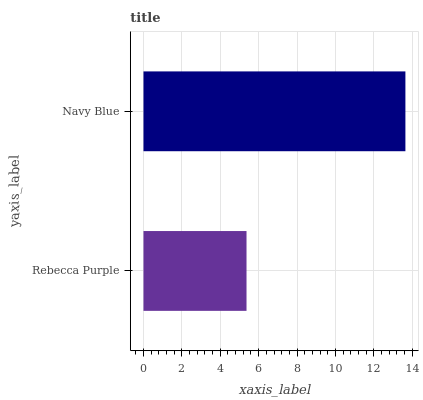Is Rebecca Purple the minimum?
Answer yes or no. Yes. Is Navy Blue the maximum?
Answer yes or no. Yes. Is Navy Blue the minimum?
Answer yes or no. No. Is Navy Blue greater than Rebecca Purple?
Answer yes or no. Yes. Is Rebecca Purple less than Navy Blue?
Answer yes or no. Yes. Is Rebecca Purple greater than Navy Blue?
Answer yes or no. No. Is Navy Blue less than Rebecca Purple?
Answer yes or no. No. Is Navy Blue the high median?
Answer yes or no. Yes. Is Rebecca Purple the low median?
Answer yes or no. Yes. Is Rebecca Purple the high median?
Answer yes or no. No. Is Navy Blue the low median?
Answer yes or no. No. 